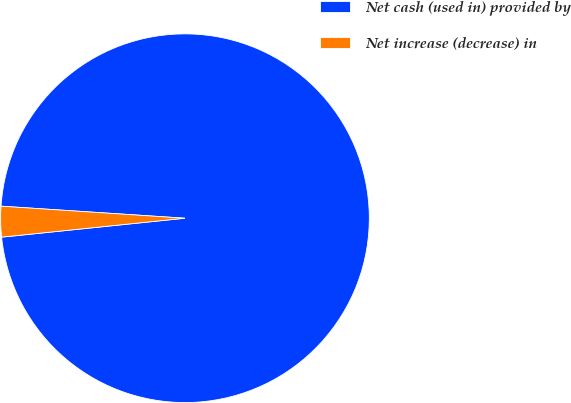Convert chart. <chart><loc_0><loc_0><loc_500><loc_500><pie_chart><fcel>Net cash (used in) provided by<fcel>Net increase (decrease) in<nl><fcel>97.32%<fcel>2.68%<nl></chart> 